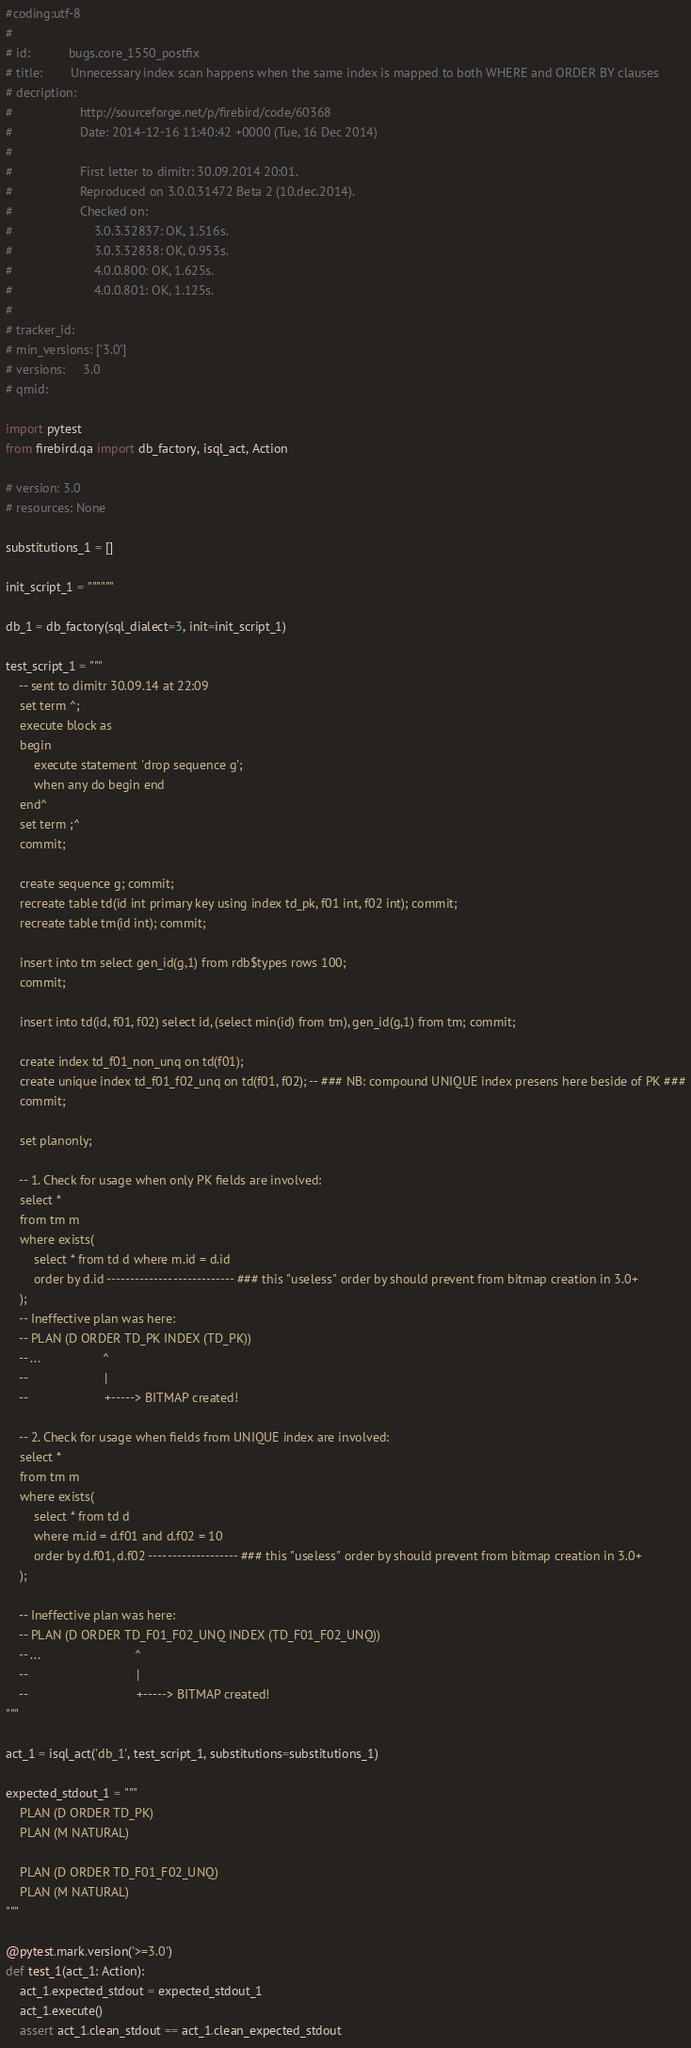Convert code to text. <code><loc_0><loc_0><loc_500><loc_500><_Python_>#coding:utf-8
#
# id:           bugs.core_1550_postfix
# title:        Unnecessary index scan happens when the same index is mapped to both WHERE and ORDER BY clauses
# decription:   
#                   http://sourceforge.net/p/firebird/code/60368
#                   Date: 2014-12-16 11:40:42 +0000 (Tue, 16 Dec 2014)
#                   
#                   First letter to dimitr: 30.09.2014 20:01.
#                   Reproduced on 3.0.0.31472 Beta 2 (10.dec.2014).
#                   Checked on:
#                       3.0.3.32837: OK, 1.516s.
#                       3.0.3.32838: OK, 0.953s.
#                       4.0.0.800: OK, 1.625s.
#                       4.0.0.801: OK, 1.125s.
#                
# tracker_id:   
# min_versions: ['3.0']
# versions:     3.0
# qmid:         

import pytest
from firebird.qa import db_factory, isql_act, Action

# version: 3.0
# resources: None

substitutions_1 = []

init_script_1 = """"""

db_1 = db_factory(sql_dialect=3, init=init_script_1)

test_script_1 = """
    -- sent to dimitr 30.09.14 at 22:09
    set term ^;
    execute block as
    begin
        execute statement 'drop sequence g';
        when any do begin end
    end^
    set term ;^
    commit;

    create sequence g; commit;
    recreate table td(id int primary key using index td_pk, f01 int, f02 int); commit;
    recreate table tm(id int); commit;

    insert into tm select gen_id(g,1) from rdb$types rows 100;
    commit;

    insert into td(id, f01, f02) select id, (select min(id) from tm), gen_id(g,1) from tm; commit;

    create index td_f01_non_unq on td(f01);
    create unique index td_f01_f02_unq on td(f01, f02); -- ### NB: compound UNIQUE index presens here beside of PK ###
    commit;

    set planonly;

    -- 1. Check for usage when only PK fields are involved:
    select *
    from tm m
    where exists(
        select * from td d where m.id = d.id 
        order by d.id --------------------------- ### this "useless" order by should prevent from bitmap creation in 3.0+
    );
    -- Ineffective plan was here:
    -- PLAN (D ORDER TD_PK INDEX (TD_PK))
    -- ...                  ^
    --                      |
    --                      +-----> BITMAP created!
     
    -- 2. Check for usage when fields from UNIQUE index are involved:
    select *
    from tm m
    where exists(
        select * from td d 
        where m.id = d.f01 and d.f02 = 10 
        order by d.f01, d.f02 ------------------- ### this "useless" order by should prevent from bitmap creation in 3.0+
    );

    -- Ineffective plan was here:
    -- PLAN (D ORDER TD_F01_F02_UNQ INDEX (TD_F01_F02_UNQ))
    -- ...                           ^
    --                               |
    --                               +-----> BITMAP created!
"""

act_1 = isql_act('db_1', test_script_1, substitutions=substitutions_1)

expected_stdout_1 = """
    PLAN (D ORDER TD_PK)
    PLAN (M NATURAL)

    PLAN (D ORDER TD_F01_F02_UNQ)
    PLAN (M NATURAL)
"""

@pytest.mark.version('>=3.0')
def test_1(act_1: Action):
    act_1.expected_stdout = expected_stdout_1
    act_1.execute()
    assert act_1.clean_stdout == act_1.clean_expected_stdout

</code> 